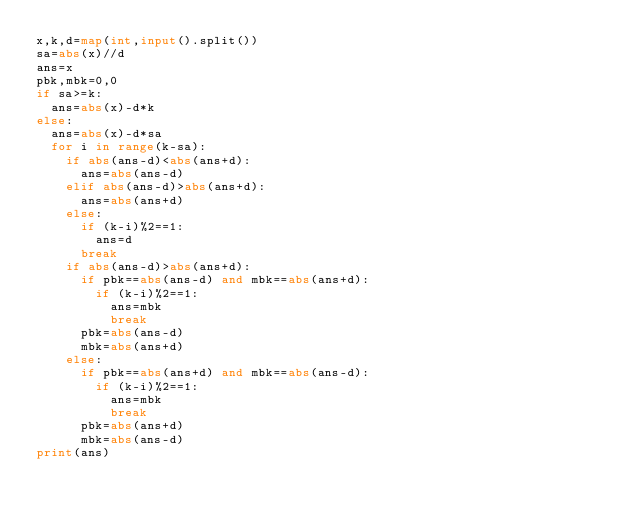Convert code to text. <code><loc_0><loc_0><loc_500><loc_500><_Python_>x,k,d=map(int,input().split())
sa=abs(x)//d
ans=x
pbk,mbk=0,0
if sa>=k:
  ans=abs(x)-d*k
else:
  ans=abs(x)-d*sa
  for i in range(k-sa):
    if abs(ans-d)<abs(ans+d):
      ans=abs(ans-d)
    elif abs(ans-d)>abs(ans+d):
      ans=abs(ans+d)
    else:
      if (k-i)%2==1:
        ans=d
      break
    if abs(ans-d)>abs(ans+d):
      if pbk==abs(ans-d) and mbk==abs(ans+d):
        if (k-i)%2==1:
          ans=mbk
          break
      pbk=abs(ans-d)
      mbk=abs(ans+d)
    else:
      if pbk==abs(ans+d) and mbk==abs(ans-d):
        if (k-i)%2==1:
          ans=mbk
          break
      pbk=abs(ans+d)
      mbk=abs(ans-d)
print(ans)</code> 